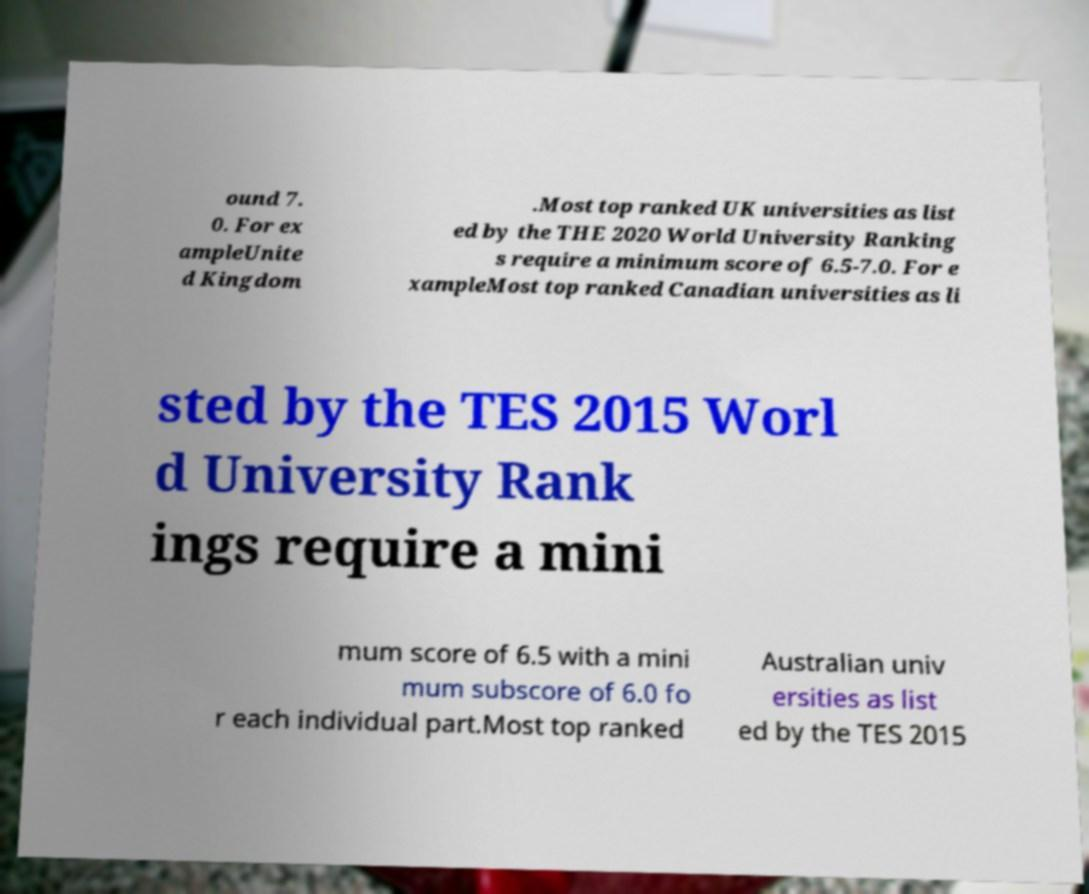Please identify and transcribe the text found in this image. ound 7. 0. For ex ampleUnite d Kingdom .Most top ranked UK universities as list ed by the THE 2020 World University Ranking s require a minimum score of 6.5-7.0. For e xampleMost top ranked Canadian universities as li sted by the TES 2015 Worl d University Rank ings require a mini mum score of 6.5 with a mini mum subscore of 6.0 fo r each individual part.Most top ranked Australian univ ersities as list ed by the TES 2015 